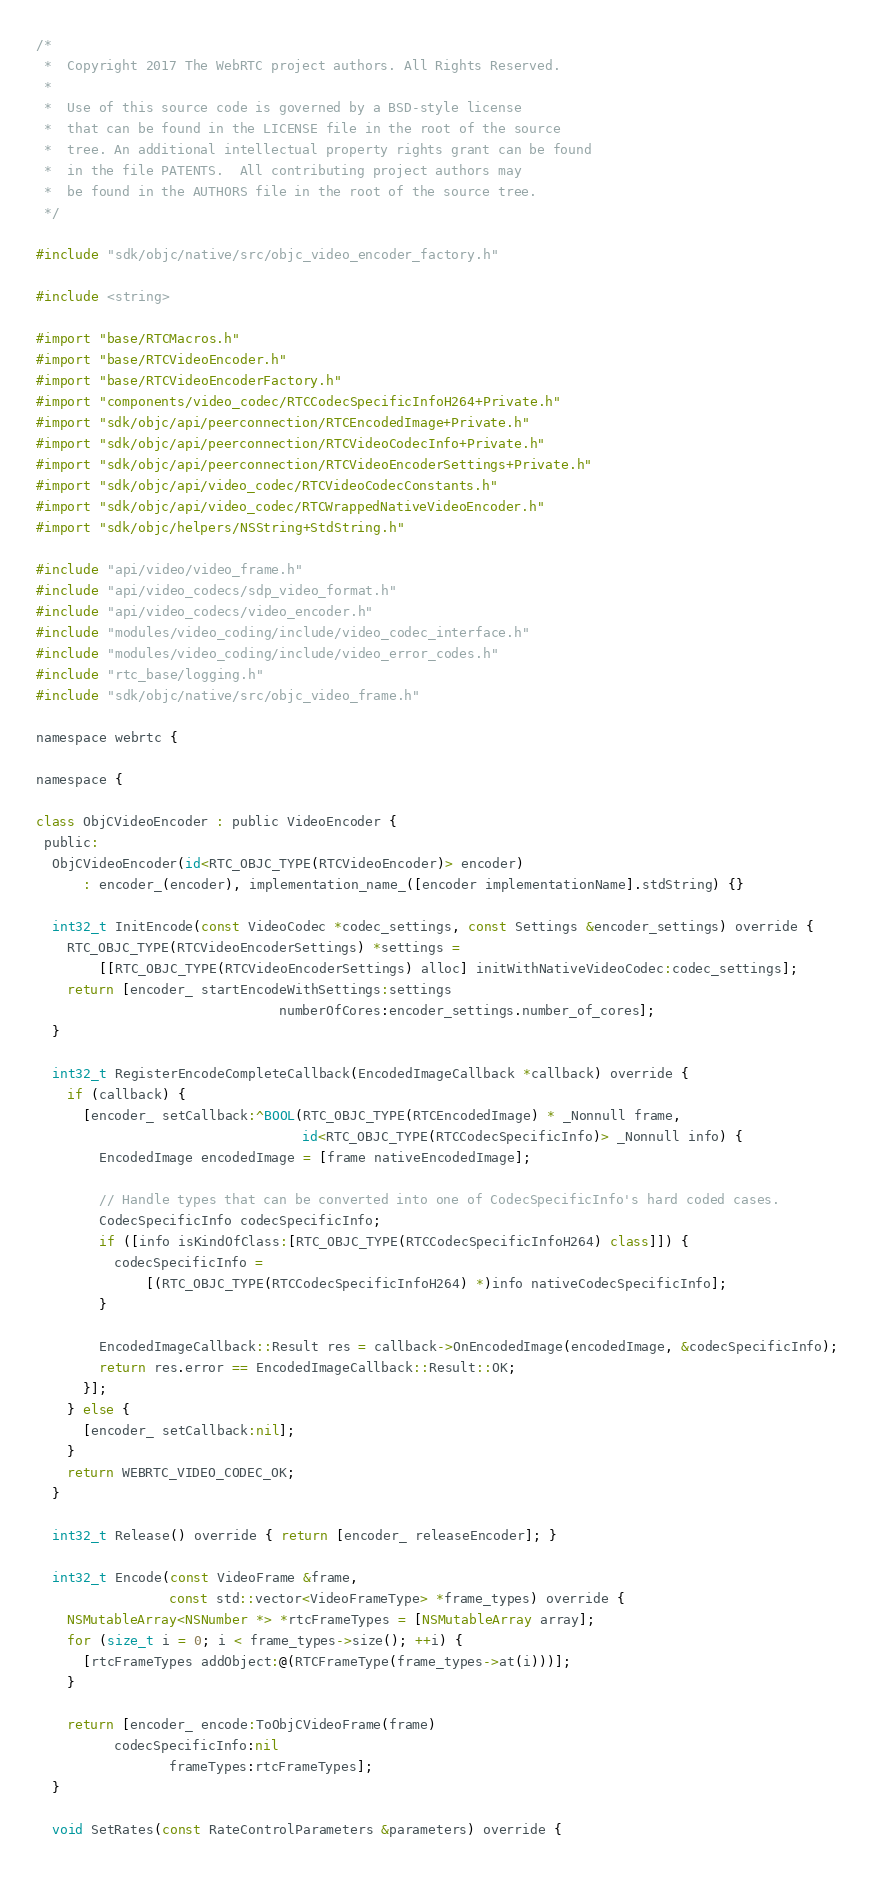Convert code to text. <code><loc_0><loc_0><loc_500><loc_500><_ObjectiveC_>/*
 *  Copyright 2017 The WebRTC project authors. All Rights Reserved.
 *
 *  Use of this source code is governed by a BSD-style license
 *  that can be found in the LICENSE file in the root of the source
 *  tree. An additional intellectual property rights grant can be found
 *  in the file PATENTS.  All contributing project authors may
 *  be found in the AUTHORS file in the root of the source tree.
 */

#include "sdk/objc/native/src/objc_video_encoder_factory.h"

#include <string>

#import "base/RTCMacros.h"
#import "base/RTCVideoEncoder.h"
#import "base/RTCVideoEncoderFactory.h"
#import "components/video_codec/RTCCodecSpecificInfoH264+Private.h"
#import "sdk/objc/api/peerconnection/RTCEncodedImage+Private.h"
#import "sdk/objc/api/peerconnection/RTCVideoCodecInfo+Private.h"
#import "sdk/objc/api/peerconnection/RTCVideoEncoderSettings+Private.h"
#import "sdk/objc/api/video_codec/RTCVideoCodecConstants.h"
#import "sdk/objc/api/video_codec/RTCWrappedNativeVideoEncoder.h"
#import "sdk/objc/helpers/NSString+StdString.h"

#include "api/video/video_frame.h"
#include "api/video_codecs/sdp_video_format.h"
#include "api/video_codecs/video_encoder.h"
#include "modules/video_coding/include/video_codec_interface.h"
#include "modules/video_coding/include/video_error_codes.h"
#include "rtc_base/logging.h"
#include "sdk/objc/native/src/objc_video_frame.h"

namespace webrtc {

namespace {

class ObjCVideoEncoder : public VideoEncoder {
 public:
  ObjCVideoEncoder(id<RTC_OBJC_TYPE(RTCVideoEncoder)> encoder)
      : encoder_(encoder), implementation_name_([encoder implementationName].stdString) {}

  int32_t InitEncode(const VideoCodec *codec_settings, const Settings &encoder_settings) override {
    RTC_OBJC_TYPE(RTCVideoEncoderSettings) *settings =
        [[RTC_OBJC_TYPE(RTCVideoEncoderSettings) alloc] initWithNativeVideoCodec:codec_settings];
    return [encoder_ startEncodeWithSettings:settings
                               numberOfCores:encoder_settings.number_of_cores];
  }

  int32_t RegisterEncodeCompleteCallback(EncodedImageCallback *callback) override {
    if (callback) {
      [encoder_ setCallback:^BOOL(RTC_OBJC_TYPE(RTCEncodedImage) * _Nonnull frame,
                                  id<RTC_OBJC_TYPE(RTCCodecSpecificInfo)> _Nonnull info) {
        EncodedImage encodedImage = [frame nativeEncodedImage];

        // Handle types that can be converted into one of CodecSpecificInfo's hard coded cases.
        CodecSpecificInfo codecSpecificInfo;
        if ([info isKindOfClass:[RTC_OBJC_TYPE(RTCCodecSpecificInfoH264) class]]) {
          codecSpecificInfo =
              [(RTC_OBJC_TYPE(RTCCodecSpecificInfoH264) *)info nativeCodecSpecificInfo];
        }

        EncodedImageCallback::Result res = callback->OnEncodedImage(encodedImage, &codecSpecificInfo);
        return res.error == EncodedImageCallback::Result::OK;
      }];
    } else {
      [encoder_ setCallback:nil];
    }
    return WEBRTC_VIDEO_CODEC_OK;
  }

  int32_t Release() override { return [encoder_ releaseEncoder]; }

  int32_t Encode(const VideoFrame &frame,
                 const std::vector<VideoFrameType> *frame_types) override {
    NSMutableArray<NSNumber *> *rtcFrameTypes = [NSMutableArray array];
    for (size_t i = 0; i < frame_types->size(); ++i) {
      [rtcFrameTypes addObject:@(RTCFrameType(frame_types->at(i)))];
    }

    return [encoder_ encode:ToObjCVideoFrame(frame)
          codecSpecificInfo:nil
                 frameTypes:rtcFrameTypes];
  }

  void SetRates(const RateControlParameters &parameters) override {</code> 